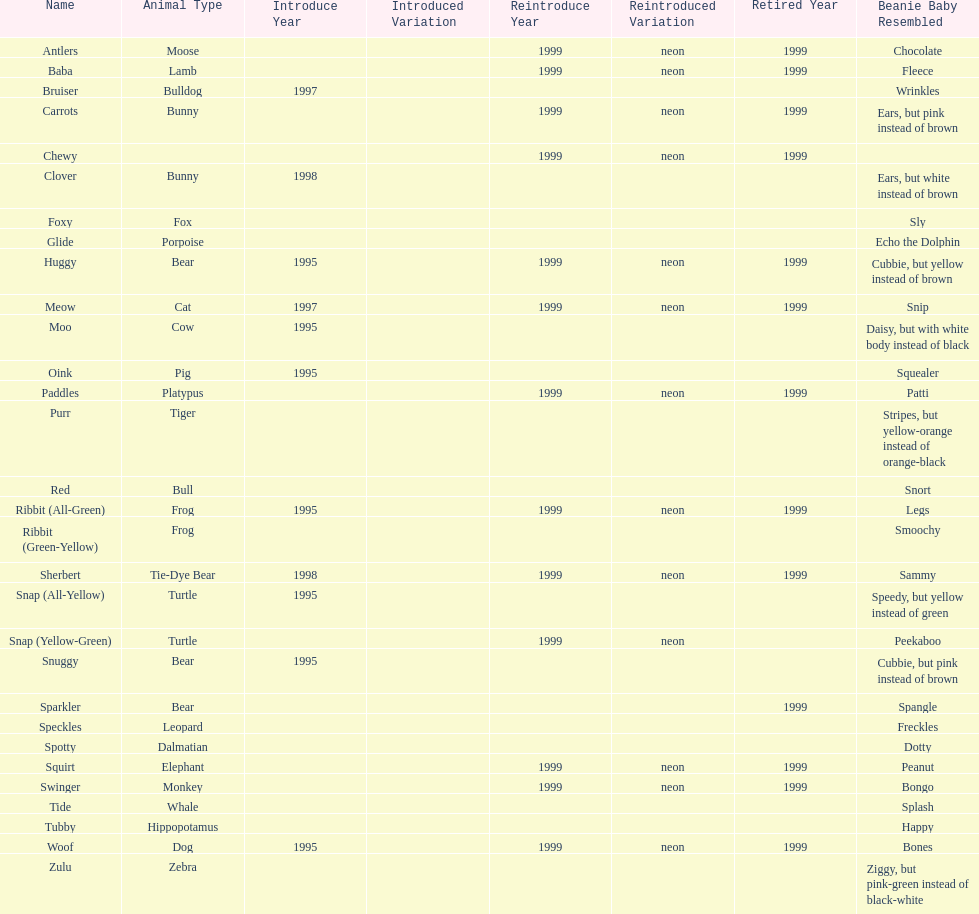Can you parse all the data within this table? {'header': ['Name', 'Animal Type', 'Introduce Year', 'Introduced Variation', 'Reintroduce Year', 'Reintroduced Variation', 'Retired Year', 'Beanie Baby Resembled'], 'rows': [['Antlers', 'Moose', '', '', '1999', 'neon', '1999', 'Chocolate'], ['Baba', 'Lamb', '', '', '1999', 'neon', '1999', 'Fleece'], ['Bruiser', 'Bulldog', '1997', '', '', '', '', 'Wrinkles'], ['Carrots', 'Bunny', '', '', '1999', 'neon', '1999', 'Ears, but pink instead of brown'], ['Chewy', '', '', '', '1999', 'neon', '1999', ''], ['Clover', 'Bunny', '1998', '', '', '', '', 'Ears, but white instead of brown'], ['Foxy', 'Fox', '', '', '', '', '', 'Sly'], ['Glide', 'Porpoise', '', '', '', '', '', 'Echo the Dolphin'], ['Huggy', 'Bear', '1995', '', '1999', 'neon', '1999', 'Cubbie, but yellow instead of brown'], ['Meow', 'Cat', '1997', '', '1999', 'neon', '1999', 'Snip'], ['Moo', 'Cow', '1995', '', '', '', '', 'Daisy, but with white body instead of black'], ['Oink', 'Pig', '1995', '', '', '', '', 'Squealer'], ['Paddles', 'Platypus', '', '', '1999', 'neon', '1999', 'Patti'], ['Purr', 'Tiger', '', '', '', '', '', 'Stripes, but yellow-orange instead of orange-black'], ['Red', 'Bull', '', '', '', '', '', 'Snort'], ['Ribbit (All-Green)', 'Frog', '1995', '', '1999', 'neon', '1999', 'Legs'], ['Ribbit (Green-Yellow)', 'Frog', '', '', '', '', '', 'Smoochy'], ['Sherbert', 'Tie-Dye Bear', '1998', '', '1999', 'neon', '1999', 'Sammy'], ['Snap (All-Yellow)', 'Turtle', '1995', '', '', '', '', 'Speedy, but yellow instead of green'], ['Snap (Yellow-Green)', 'Turtle', '', '', '1999', 'neon', '', 'Peekaboo'], ['Snuggy', 'Bear', '1995', '', '', '', '', 'Cubbie, but pink instead of brown'], ['Sparkler', 'Bear', '', '', '', '', '1999', 'Spangle'], ['Speckles', 'Leopard', '', '', '', '', '', 'Freckles'], ['Spotty', 'Dalmatian', '', '', '', '', '', 'Dotty'], ['Squirt', 'Elephant', '', '', '1999', 'neon', '1999', 'Peanut'], ['Swinger', 'Monkey', '', '', '1999', 'neon', '1999', 'Bongo'], ['Tide', 'Whale', '', '', '', '', '', 'Splash'], ['Tubby', 'Hippopotamus', '', '', '', '', '', 'Happy'], ['Woof', 'Dog', '1995', '', '1999', 'neon', '1999', 'Bones'], ['Zulu', 'Zebra', '', '', '', '', '', 'Ziggy, but pink-green instead of black-white']]} In what year were the first pillow pals introduced? 1995. 